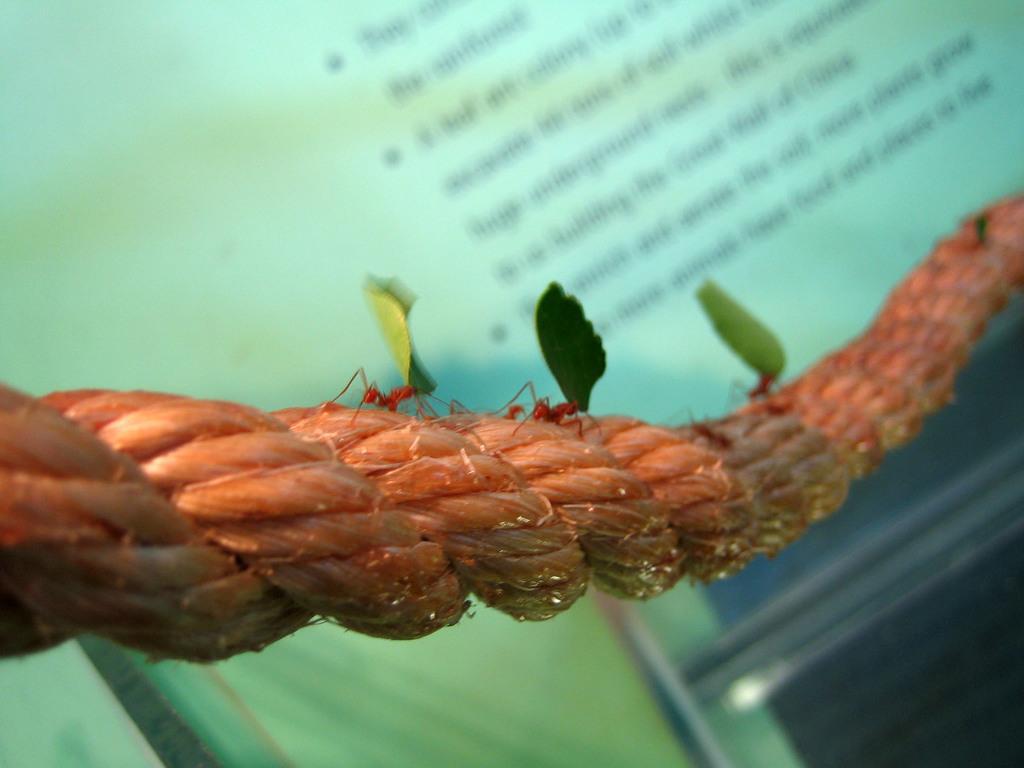How would you summarize this image in a sentence or two? In this image, we can see a rope, ants and leaves. Background there is a blur view. Here we can see some text and rod. 